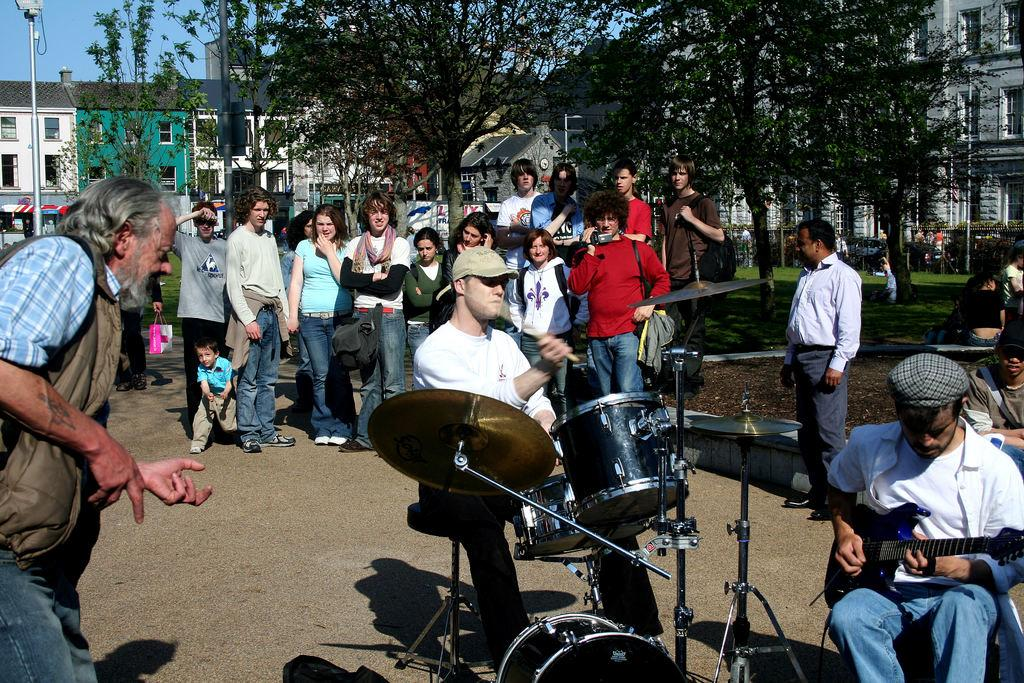What are the people in the image doing? There are people standing in the image, and a man is playing the guitar, while another man is playing the drums. What can be seen in the background of the image? There is a building and trees visible in the background of the image? What type of linen is being used to protest in the image? There is no protest or linen present in the image. What type of coat is the man playing the guitar wearing in the image? The image does not provide information about the man's coat, as it only shows people standing and playing musical instruments. 